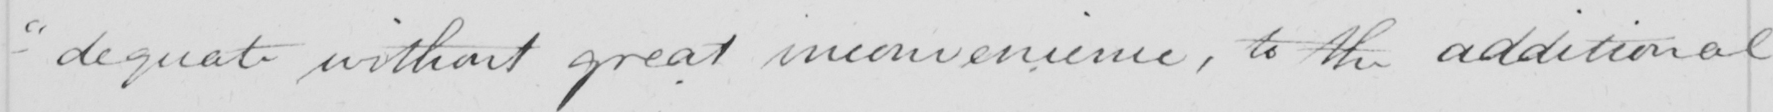Can you read and transcribe this handwriting? - " dequate without great inconvenience , to the additional 